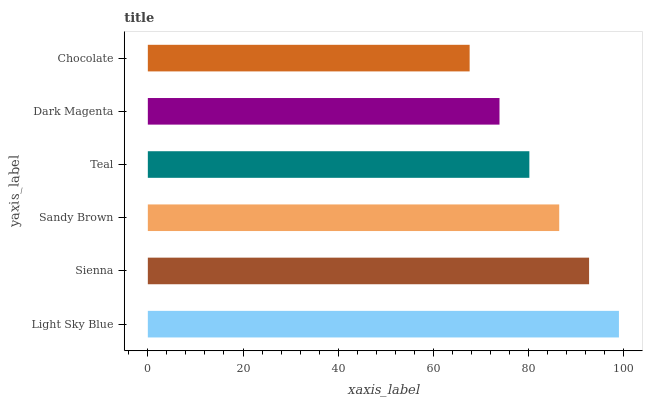Is Chocolate the minimum?
Answer yes or no. Yes. Is Light Sky Blue the maximum?
Answer yes or no. Yes. Is Sienna the minimum?
Answer yes or no. No. Is Sienna the maximum?
Answer yes or no. No. Is Light Sky Blue greater than Sienna?
Answer yes or no. Yes. Is Sienna less than Light Sky Blue?
Answer yes or no. Yes. Is Sienna greater than Light Sky Blue?
Answer yes or no. No. Is Light Sky Blue less than Sienna?
Answer yes or no. No. Is Sandy Brown the high median?
Answer yes or no. Yes. Is Teal the low median?
Answer yes or no. Yes. Is Dark Magenta the high median?
Answer yes or no. No. Is Sienna the low median?
Answer yes or no. No. 